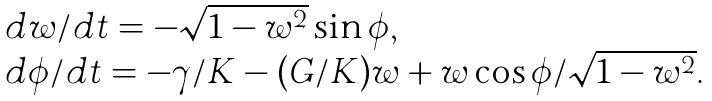Convert formula to latex. <formula><loc_0><loc_0><loc_500><loc_500>\begin{array} { l } d w / d t = - \sqrt { 1 - w ^ { 2 } } \sin \phi , \\ d \phi / d t = - \gamma / K - ( G / K ) w + w \cos \phi / \sqrt { 1 - w ^ { 2 } } . \end{array}</formula> 